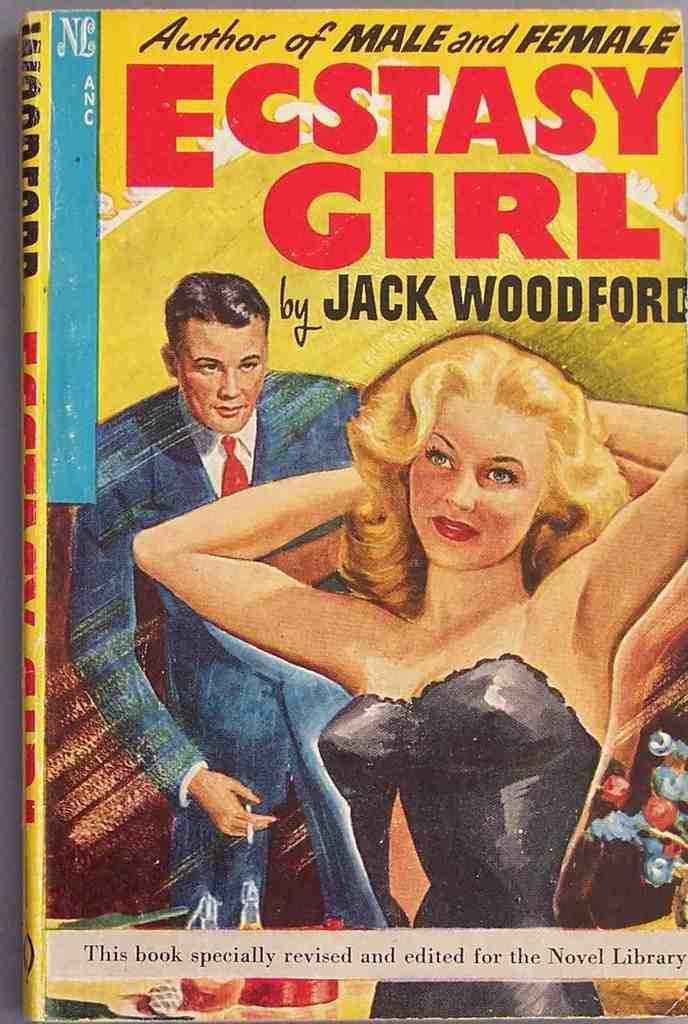What is the sign warning us of?
Make the answer very short. Unanswerable. Is this an old magazine by jack woodford?
Offer a terse response. Yes. 